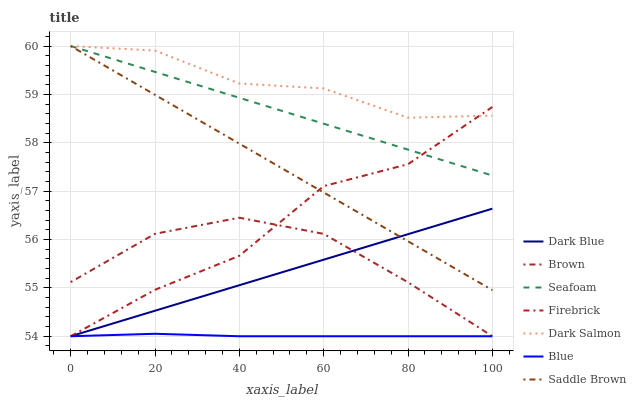Does Brown have the minimum area under the curve?
Answer yes or no. No. Does Brown have the maximum area under the curve?
Answer yes or no. No. Is Brown the smoothest?
Answer yes or no. No. Is Brown the roughest?
Answer yes or no. No. Does Dark Salmon have the lowest value?
Answer yes or no. No. Does Brown have the highest value?
Answer yes or no. No. Is Blue less than Saddle Brown?
Answer yes or no. Yes. Is Saddle Brown greater than Brown?
Answer yes or no. Yes. Does Blue intersect Saddle Brown?
Answer yes or no. No. 